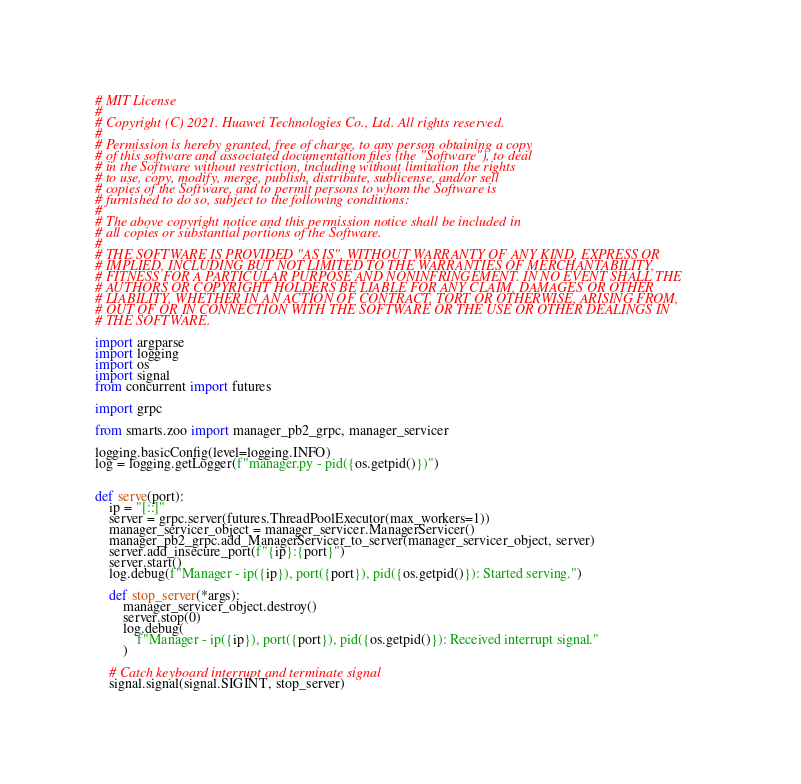<code> <loc_0><loc_0><loc_500><loc_500><_Python_># MIT License
#
# Copyright (C) 2021. Huawei Technologies Co., Ltd. All rights reserved.
#
# Permission is hereby granted, free of charge, to any person obtaining a copy
# of this software and associated documentation files (the "Software"), to deal
# in the Software without restriction, including without limitation the rights
# to use, copy, modify, merge, publish, distribute, sublicense, and/or sell
# copies of the Software, and to permit persons to whom the Software is
# furnished to do so, subject to the following conditions:
#
# The above copyright notice and this permission notice shall be included in
# all copies or substantial portions of the Software.
#
# THE SOFTWARE IS PROVIDED "AS IS", WITHOUT WARRANTY OF ANY KIND, EXPRESS OR
# IMPLIED, INCLUDING BUT NOT LIMITED TO THE WARRANTIES OF MERCHANTABILITY,
# FITNESS FOR A PARTICULAR PURPOSE AND NONINFRINGEMENT. IN NO EVENT SHALL THE
# AUTHORS OR COPYRIGHT HOLDERS BE LIABLE FOR ANY CLAIM, DAMAGES OR OTHER
# LIABILITY, WHETHER IN AN ACTION OF CONTRACT, TORT OR OTHERWISE, ARISING FROM,
# OUT OF OR IN CONNECTION WITH THE SOFTWARE OR THE USE OR OTHER DEALINGS IN
# THE SOFTWARE.

import argparse
import logging
import os
import signal
from concurrent import futures

import grpc

from smarts.zoo import manager_pb2_grpc, manager_servicer

logging.basicConfig(level=logging.INFO)
log = logging.getLogger(f"manager.py - pid({os.getpid()})")


def serve(port):
    ip = "[::]"
    server = grpc.server(futures.ThreadPoolExecutor(max_workers=1))
    manager_servicer_object = manager_servicer.ManagerServicer()
    manager_pb2_grpc.add_ManagerServicer_to_server(manager_servicer_object, server)
    server.add_insecure_port(f"{ip}:{port}")
    server.start()
    log.debug(f"Manager - ip({ip}), port({port}), pid({os.getpid()}): Started serving.")

    def stop_server(*args):
        manager_servicer_object.destroy()
        server.stop(0)
        log.debug(
            f"Manager - ip({ip}), port({port}), pid({os.getpid()}): Received interrupt signal."
        )

    # Catch keyboard interrupt and terminate signal
    signal.signal(signal.SIGINT, stop_server)</code> 